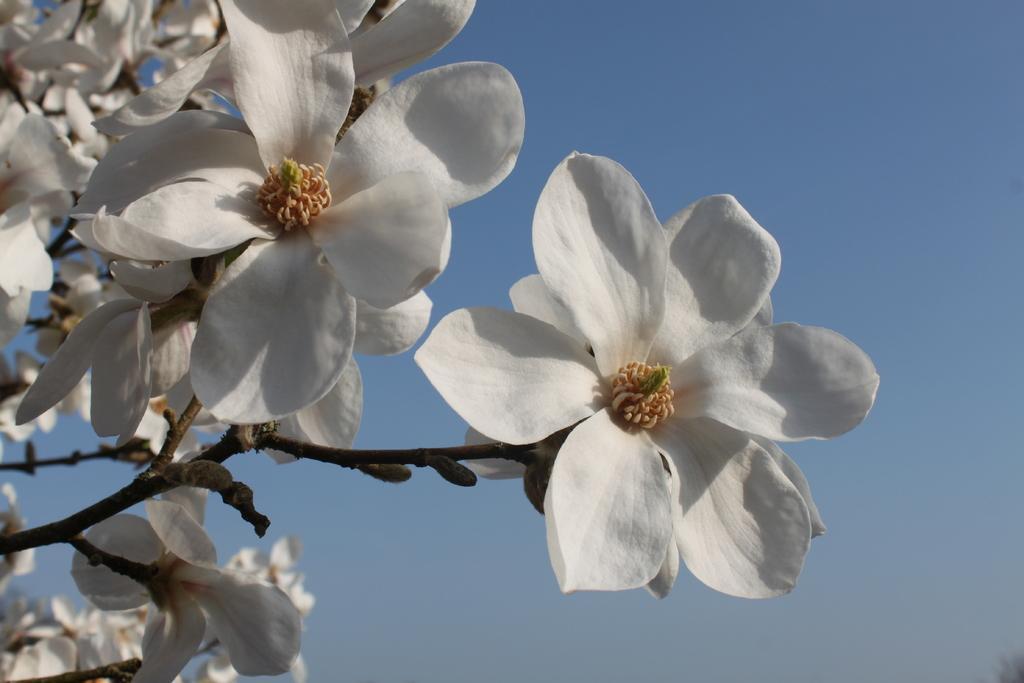Describe this image in one or two sentences. In this there are picture flowers and stems of a tree. Sky is clear and it is sunny. 